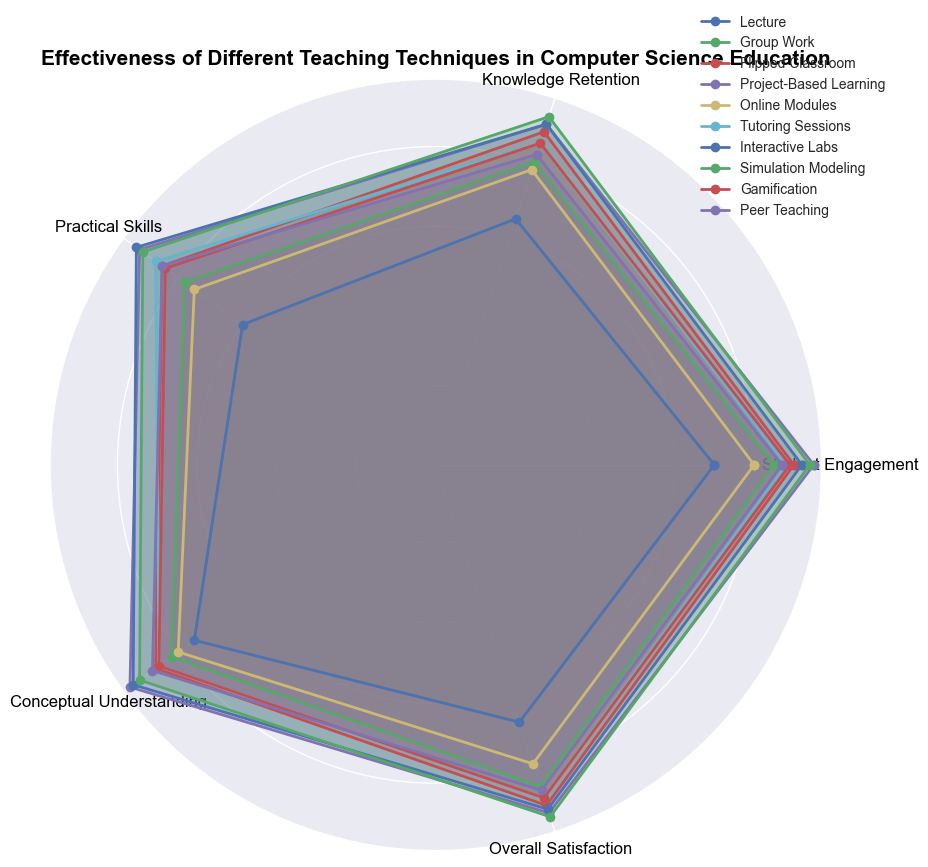Which teaching technique has the highest overall satisfaction? The figure shows the overall satisfaction scores for each technique. The highest rated value corresponds to "Simulation Modeling" with a score of 93.
Answer: Simulation Modeling How does the student engagement in Group Work compare to that in Lecture? By visually comparing the lengths of the lines for student engagement in both techniques, Group Work appears notably higher with 85 compared to Lecture's 70.
Answer: Group Work What is the average practical skills score across all techniques? First, sum the practical skills scores for all techniques (60 + 78 + 85 + 92 + 75 + 87 + 93 + 91 + 84 + 85) which equals 830. There are 10 techniques, so the average is 830 / 10.
Answer: 83 What is the difference in conceptual understanding between Interactive Labs and Online Modules? The conceptual understanding score for Interactive Labs is 94 and for Online Modules is 80. The difference is 94 - 80.
Answer: 14 Which technique other than Project-Based Learning has the highest knowledge retention? Looking at the knowledge retention scores, after Project-Based Learning (90), Flipped Classroom and Interactive Labs share the next highest score of 90.
Answer: Flipped Classroom, Interactive Labs Which techniques scored above 85 in student engagement? By examining the student engagement scores in the figure, Group Work (85), Flipped Classroom (90), Project-Based Learning (95), Tutoring Sessions (88), Interactive Labs (92), Simulation Modeling (94), Gamification (89), and Peer Teaching (87) scored above 85.
Answer: Group Work, Flipped Classroom, Project-Based Learning, Tutoring Sessions, Interactive Labs, Simulation Modeling, Gamification, Peer Teaching What is the median overall satisfaction score? List overall satisfaction scores: (68, 79, 85, 86, 88, 88, 90, 91, 92, 93). The median of an ordered list of 10 numbers is the average of the 5th and 6th values, (88 + 88) / 2.
Answer: 88 Which technique shows the highest practical skills improvement? From the practical skills scores, the technique with the highest score is Interactive Labs with 93, closely followed by Project-Based Learning at 92.
Answer: Interactive Labs Is the knowledge retention for Peer Teaching higher than that for Group Work? The knowledge retention score for Peer Teaching is 82, while for Group Work it's 80. Peer Teaching's score is higher.
Answer: Yes 